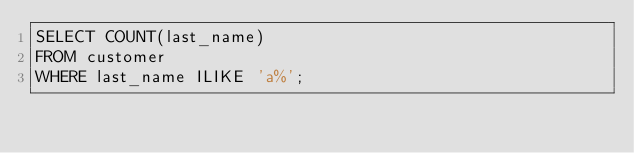<code> <loc_0><loc_0><loc_500><loc_500><_SQL_>SELECT COUNT(last_name)
FROM customer
WHERE last_name ILIKE 'a%';</code> 